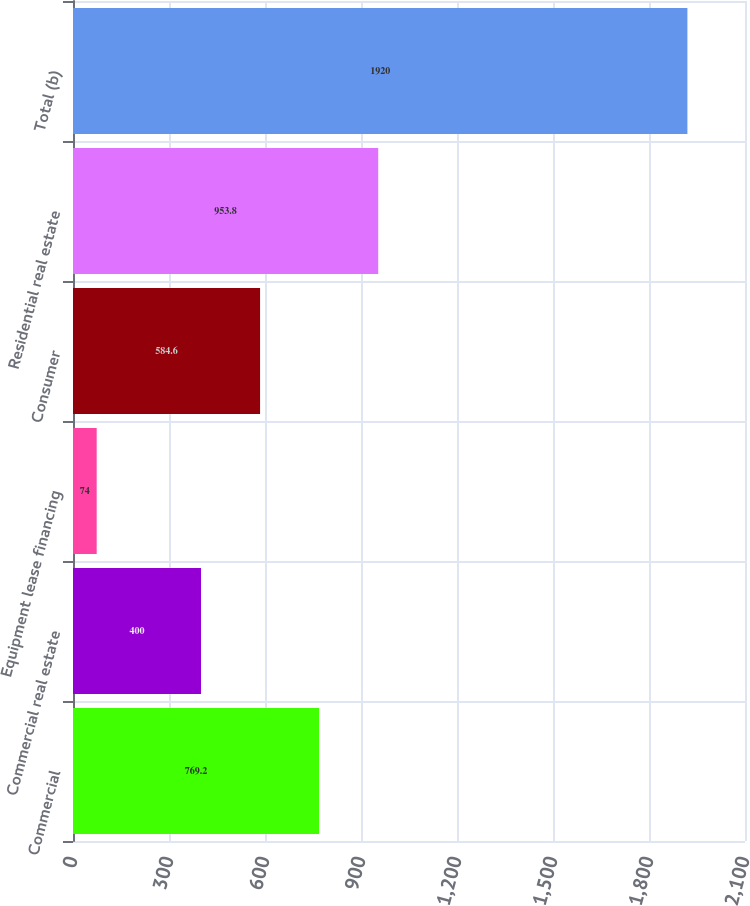<chart> <loc_0><loc_0><loc_500><loc_500><bar_chart><fcel>Commercial<fcel>Commercial real estate<fcel>Equipment lease financing<fcel>Consumer<fcel>Residential real estate<fcel>Total (b)<nl><fcel>769.2<fcel>400<fcel>74<fcel>584.6<fcel>953.8<fcel>1920<nl></chart> 